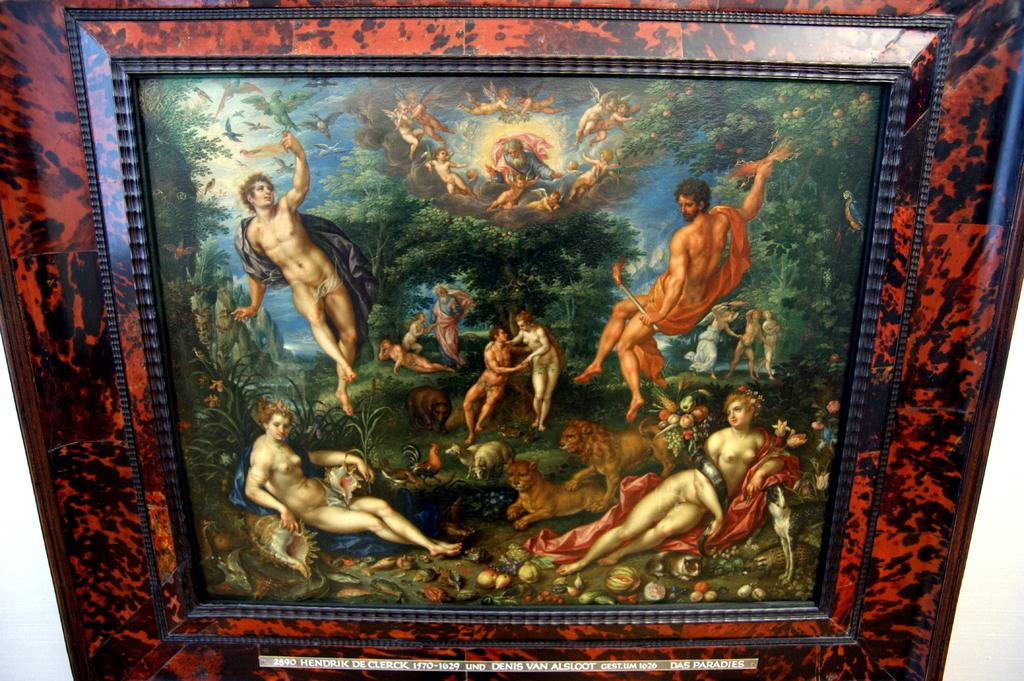<image>
Present a compact description of the photo's key features. A famous oil painting titled "Das Paradies" boasts an ornate red frame. 